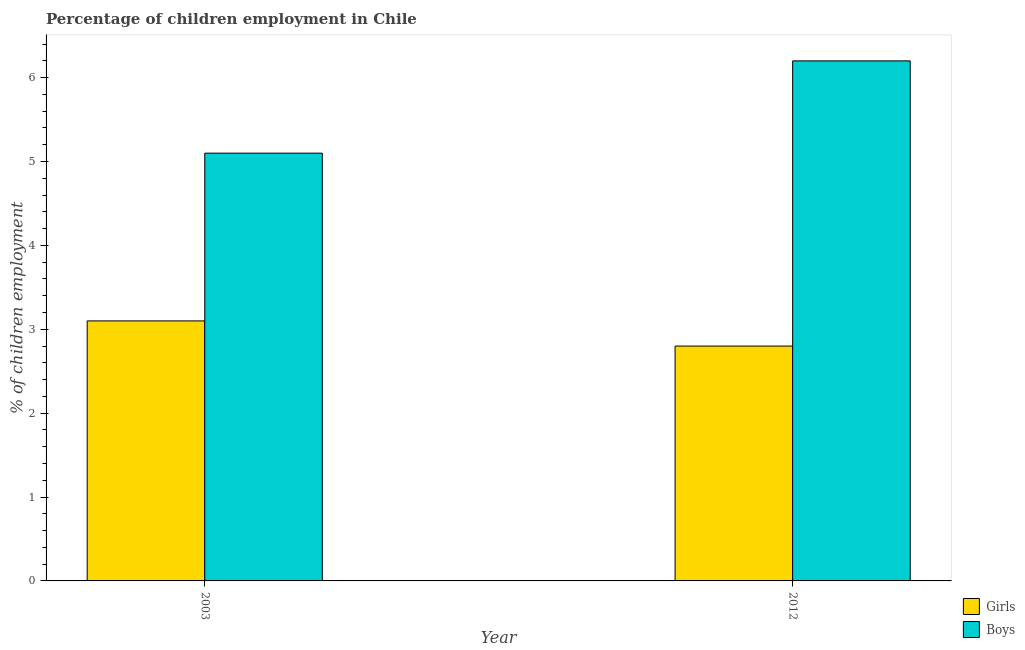How many different coloured bars are there?
Make the answer very short. 2. How many groups of bars are there?
Provide a succinct answer. 2. Are the number of bars per tick equal to the number of legend labels?
Keep it short and to the point. Yes. Are the number of bars on each tick of the X-axis equal?
Offer a very short reply. Yes. How many bars are there on the 2nd tick from the right?
Ensure brevity in your answer.  2. Across all years, what is the maximum percentage of employed boys?
Your answer should be compact. 6.2. In which year was the percentage of employed boys maximum?
Offer a terse response. 2012. In which year was the percentage of employed girls minimum?
Your answer should be very brief. 2012. What is the total percentage of employed boys in the graph?
Your answer should be very brief. 11.3. What is the difference between the percentage of employed girls in 2003 and that in 2012?
Offer a very short reply. 0.3. What is the difference between the percentage of employed boys in 2012 and the percentage of employed girls in 2003?
Keep it short and to the point. 1.1. What is the average percentage of employed girls per year?
Provide a short and direct response. 2.95. In the year 2012, what is the difference between the percentage of employed girls and percentage of employed boys?
Provide a short and direct response. 0. What is the ratio of the percentage of employed boys in 2003 to that in 2012?
Provide a succinct answer. 0.82. Is the percentage of employed boys in 2003 less than that in 2012?
Keep it short and to the point. Yes. What does the 1st bar from the left in 2003 represents?
Give a very brief answer. Girls. What does the 1st bar from the right in 2012 represents?
Your answer should be very brief. Boys. Are all the bars in the graph horizontal?
Make the answer very short. No. How many years are there in the graph?
Your response must be concise. 2. Does the graph contain grids?
Provide a short and direct response. No. Where does the legend appear in the graph?
Your response must be concise. Bottom right. How many legend labels are there?
Ensure brevity in your answer.  2. What is the title of the graph?
Give a very brief answer. Percentage of children employment in Chile. Does "Start a business" appear as one of the legend labels in the graph?
Your response must be concise. No. What is the label or title of the Y-axis?
Keep it short and to the point. % of children employment. What is the % of children employment in Girls in 2003?
Give a very brief answer. 3.1. What is the % of children employment of Boys in 2003?
Your answer should be compact. 5.1. What is the % of children employment of Boys in 2012?
Your response must be concise. 6.2. Across all years, what is the maximum % of children employment of Boys?
Your answer should be compact. 6.2. What is the total % of children employment of Girls in the graph?
Provide a succinct answer. 5.9. What is the difference between the % of children employment in Boys in 2003 and that in 2012?
Provide a succinct answer. -1.1. What is the difference between the % of children employment of Girls in 2003 and the % of children employment of Boys in 2012?
Keep it short and to the point. -3.1. What is the average % of children employment in Girls per year?
Give a very brief answer. 2.95. What is the average % of children employment of Boys per year?
Your response must be concise. 5.65. What is the ratio of the % of children employment of Girls in 2003 to that in 2012?
Your answer should be very brief. 1.11. What is the ratio of the % of children employment in Boys in 2003 to that in 2012?
Your answer should be very brief. 0.82. What is the difference between the highest and the second highest % of children employment of Girls?
Provide a short and direct response. 0.3. What is the difference between the highest and the lowest % of children employment in Girls?
Keep it short and to the point. 0.3. 